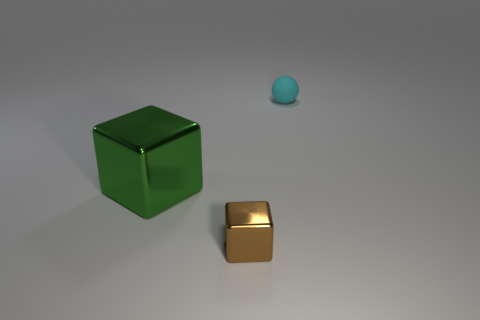Add 2 big green metallic cubes. How many objects exist? 5 Subtract all cubes. How many objects are left? 1 Add 2 brown spheres. How many brown spheres exist? 2 Subtract 0 brown cylinders. How many objects are left? 3 Subtract all brown balls. Subtract all metal cubes. How many objects are left? 1 Add 2 small balls. How many small balls are left? 3 